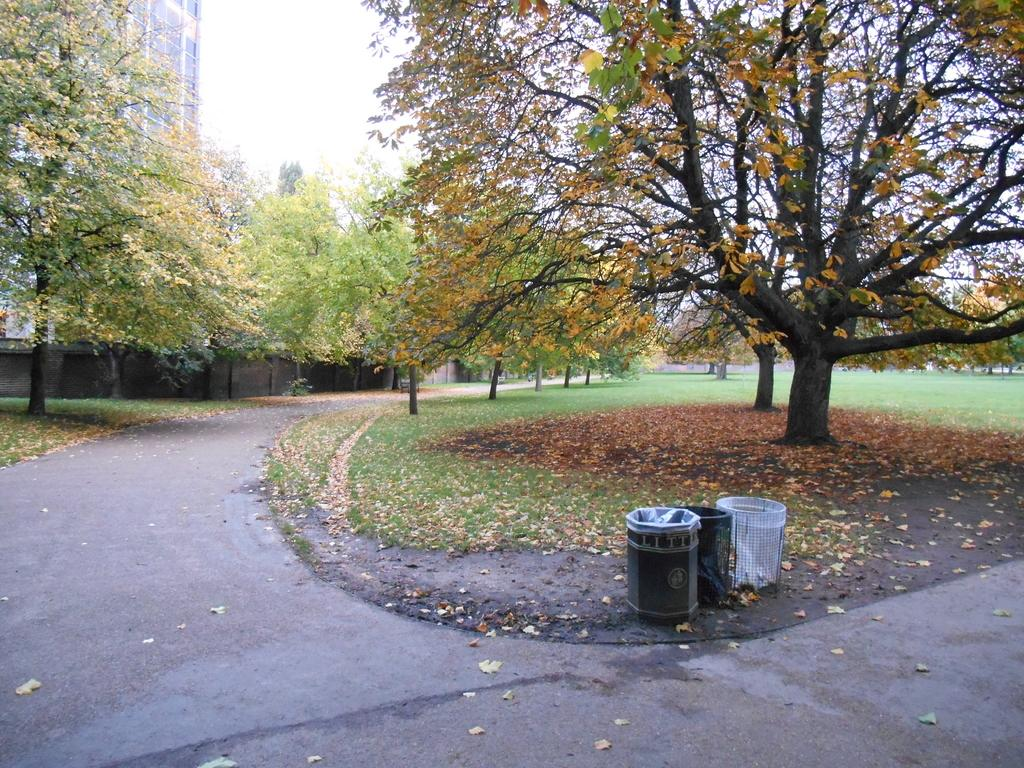What type of vegetation can be seen in the image? There are trees in the image. What type of structure is present in the image? There is a building in the image. What type of pathway is visible in the image? There is a road in the image. What type of natural ground cover is present in the image? Dry leaves and grass are present in the image. What part of the natural environment is visible in the image? The sky is visible in the image. What type of advertisement can be seen on the building in the image? There is no advertisement visible on the building in the image. What time of day is it in the image, based on the position of the dolls? There are no dolls present in the image, so it is not possible to determine the time of day based on their position. 